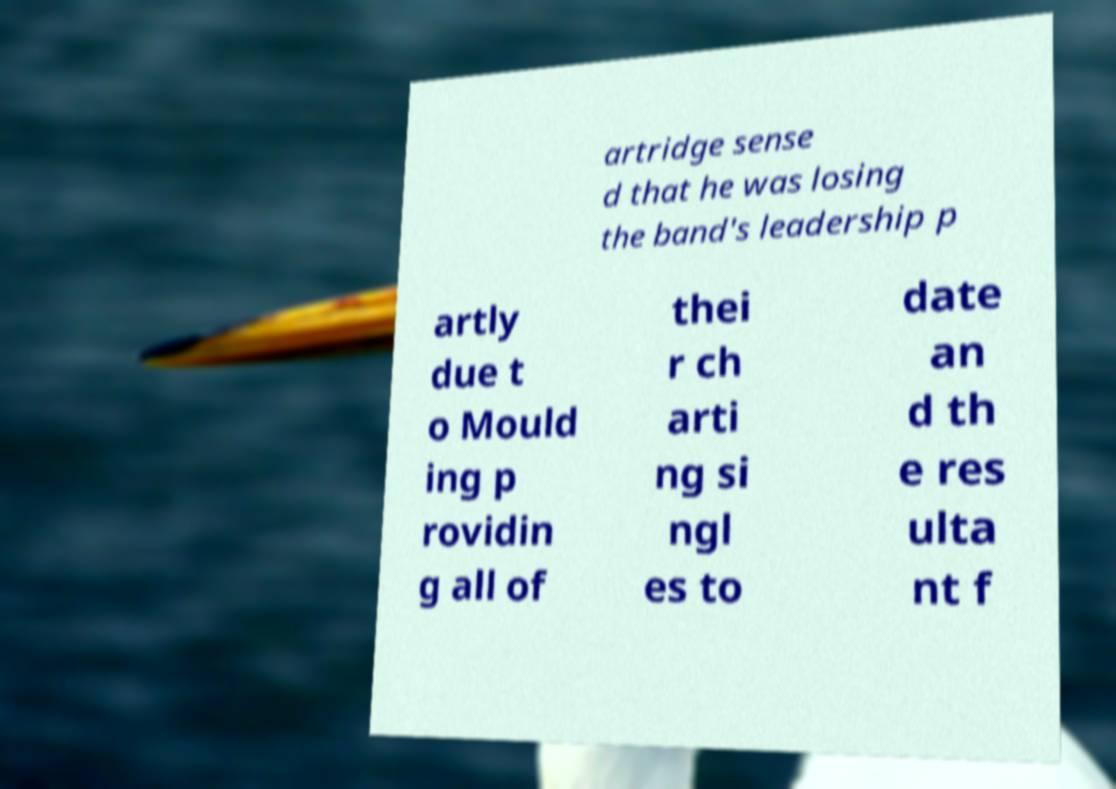Please identify and transcribe the text found in this image. artridge sense d that he was losing the band's leadership p artly due t o Mould ing p rovidin g all of thei r ch arti ng si ngl es to date an d th e res ulta nt f 